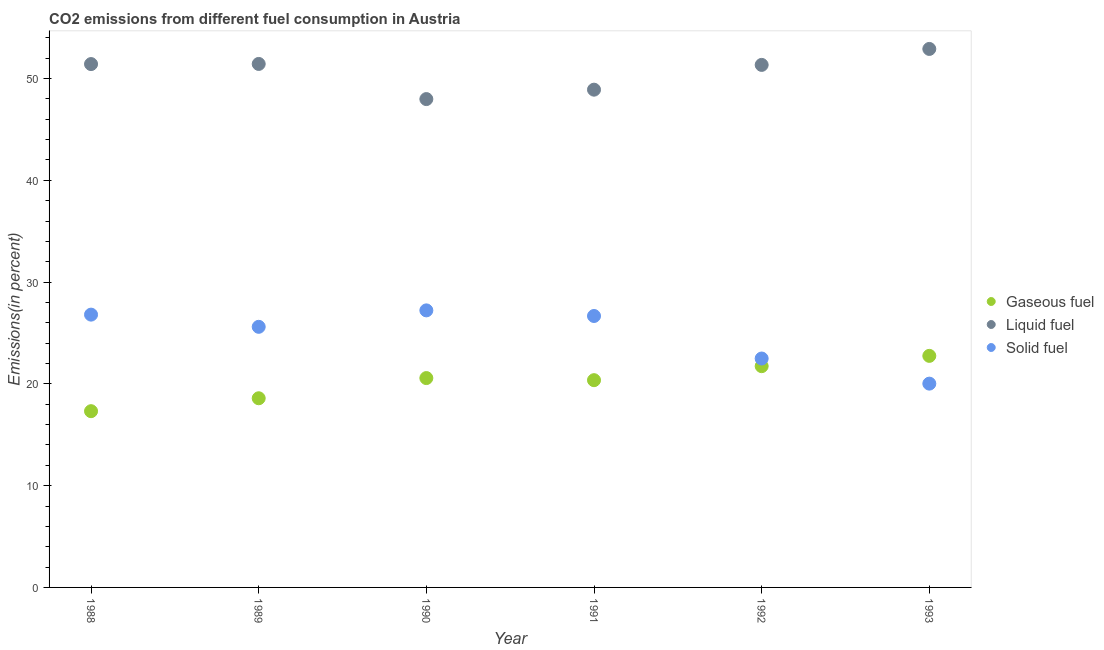How many different coloured dotlines are there?
Give a very brief answer. 3. What is the percentage of gaseous fuel emission in 1991?
Your response must be concise. 20.36. Across all years, what is the maximum percentage of liquid fuel emission?
Provide a succinct answer. 52.91. Across all years, what is the minimum percentage of gaseous fuel emission?
Keep it short and to the point. 17.32. In which year was the percentage of liquid fuel emission maximum?
Your answer should be very brief. 1993. What is the total percentage of liquid fuel emission in the graph?
Your answer should be very brief. 304. What is the difference between the percentage of gaseous fuel emission in 1992 and that in 1993?
Keep it short and to the point. -1.01. What is the difference between the percentage of gaseous fuel emission in 1993 and the percentage of solid fuel emission in 1991?
Your answer should be compact. -3.92. What is the average percentage of gaseous fuel emission per year?
Offer a very short reply. 20.22. In the year 1990, what is the difference between the percentage of liquid fuel emission and percentage of gaseous fuel emission?
Your answer should be compact. 27.41. In how many years, is the percentage of solid fuel emission greater than 20 %?
Your answer should be very brief. 6. What is the ratio of the percentage of liquid fuel emission in 1988 to that in 1993?
Your answer should be very brief. 0.97. Is the percentage of gaseous fuel emission in 1989 less than that in 1992?
Make the answer very short. Yes. What is the difference between the highest and the second highest percentage of solid fuel emission?
Your answer should be very brief. 0.42. What is the difference between the highest and the lowest percentage of solid fuel emission?
Keep it short and to the point. 7.2. In how many years, is the percentage of liquid fuel emission greater than the average percentage of liquid fuel emission taken over all years?
Your answer should be compact. 4. Does the percentage of gaseous fuel emission monotonically increase over the years?
Offer a terse response. No. Is the percentage of liquid fuel emission strictly greater than the percentage of solid fuel emission over the years?
Your answer should be compact. Yes. How many dotlines are there?
Give a very brief answer. 3. How many years are there in the graph?
Give a very brief answer. 6. What is the difference between two consecutive major ticks on the Y-axis?
Make the answer very short. 10. Are the values on the major ticks of Y-axis written in scientific E-notation?
Keep it short and to the point. No. What is the title of the graph?
Your answer should be very brief. CO2 emissions from different fuel consumption in Austria. What is the label or title of the Y-axis?
Give a very brief answer. Emissions(in percent). What is the Emissions(in percent) in Gaseous fuel in 1988?
Make the answer very short. 17.32. What is the Emissions(in percent) in Liquid fuel in 1988?
Your answer should be compact. 51.42. What is the Emissions(in percent) in Solid fuel in 1988?
Provide a short and direct response. 26.8. What is the Emissions(in percent) of Gaseous fuel in 1989?
Provide a short and direct response. 18.59. What is the Emissions(in percent) of Liquid fuel in 1989?
Your answer should be compact. 51.44. What is the Emissions(in percent) in Solid fuel in 1989?
Your answer should be very brief. 25.61. What is the Emissions(in percent) in Gaseous fuel in 1990?
Ensure brevity in your answer.  20.57. What is the Emissions(in percent) in Liquid fuel in 1990?
Offer a terse response. 47.98. What is the Emissions(in percent) in Solid fuel in 1990?
Your answer should be very brief. 27.22. What is the Emissions(in percent) in Gaseous fuel in 1991?
Provide a succinct answer. 20.36. What is the Emissions(in percent) in Liquid fuel in 1991?
Make the answer very short. 48.91. What is the Emissions(in percent) in Solid fuel in 1991?
Give a very brief answer. 26.67. What is the Emissions(in percent) in Gaseous fuel in 1992?
Offer a very short reply. 21.74. What is the Emissions(in percent) of Liquid fuel in 1992?
Provide a succinct answer. 51.34. What is the Emissions(in percent) of Solid fuel in 1992?
Offer a very short reply. 22.49. What is the Emissions(in percent) of Gaseous fuel in 1993?
Your answer should be compact. 22.75. What is the Emissions(in percent) in Liquid fuel in 1993?
Keep it short and to the point. 52.91. What is the Emissions(in percent) in Solid fuel in 1993?
Provide a short and direct response. 20.02. Across all years, what is the maximum Emissions(in percent) in Gaseous fuel?
Your answer should be very brief. 22.75. Across all years, what is the maximum Emissions(in percent) of Liquid fuel?
Ensure brevity in your answer.  52.91. Across all years, what is the maximum Emissions(in percent) of Solid fuel?
Offer a terse response. 27.22. Across all years, what is the minimum Emissions(in percent) of Gaseous fuel?
Ensure brevity in your answer.  17.32. Across all years, what is the minimum Emissions(in percent) of Liquid fuel?
Your response must be concise. 47.98. Across all years, what is the minimum Emissions(in percent) of Solid fuel?
Provide a short and direct response. 20.02. What is the total Emissions(in percent) of Gaseous fuel in the graph?
Offer a very short reply. 121.33. What is the total Emissions(in percent) in Liquid fuel in the graph?
Ensure brevity in your answer.  304. What is the total Emissions(in percent) in Solid fuel in the graph?
Ensure brevity in your answer.  148.82. What is the difference between the Emissions(in percent) of Gaseous fuel in 1988 and that in 1989?
Your response must be concise. -1.27. What is the difference between the Emissions(in percent) of Liquid fuel in 1988 and that in 1989?
Ensure brevity in your answer.  -0.01. What is the difference between the Emissions(in percent) of Solid fuel in 1988 and that in 1989?
Your response must be concise. 1.2. What is the difference between the Emissions(in percent) in Gaseous fuel in 1988 and that in 1990?
Your answer should be compact. -3.25. What is the difference between the Emissions(in percent) in Liquid fuel in 1988 and that in 1990?
Provide a short and direct response. 3.44. What is the difference between the Emissions(in percent) in Solid fuel in 1988 and that in 1990?
Offer a terse response. -0.42. What is the difference between the Emissions(in percent) in Gaseous fuel in 1988 and that in 1991?
Provide a short and direct response. -3.05. What is the difference between the Emissions(in percent) in Liquid fuel in 1988 and that in 1991?
Provide a short and direct response. 2.51. What is the difference between the Emissions(in percent) of Solid fuel in 1988 and that in 1991?
Offer a terse response. 0.13. What is the difference between the Emissions(in percent) in Gaseous fuel in 1988 and that in 1992?
Provide a succinct answer. -4.42. What is the difference between the Emissions(in percent) of Liquid fuel in 1988 and that in 1992?
Ensure brevity in your answer.  0.08. What is the difference between the Emissions(in percent) in Solid fuel in 1988 and that in 1992?
Your response must be concise. 4.31. What is the difference between the Emissions(in percent) in Gaseous fuel in 1988 and that in 1993?
Your answer should be very brief. -5.43. What is the difference between the Emissions(in percent) in Liquid fuel in 1988 and that in 1993?
Make the answer very short. -1.49. What is the difference between the Emissions(in percent) in Solid fuel in 1988 and that in 1993?
Offer a very short reply. 6.78. What is the difference between the Emissions(in percent) of Gaseous fuel in 1989 and that in 1990?
Give a very brief answer. -1.98. What is the difference between the Emissions(in percent) of Liquid fuel in 1989 and that in 1990?
Your response must be concise. 3.45. What is the difference between the Emissions(in percent) of Solid fuel in 1989 and that in 1990?
Your response must be concise. -1.62. What is the difference between the Emissions(in percent) of Gaseous fuel in 1989 and that in 1991?
Ensure brevity in your answer.  -1.78. What is the difference between the Emissions(in percent) in Liquid fuel in 1989 and that in 1991?
Your answer should be compact. 2.53. What is the difference between the Emissions(in percent) of Solid fuel in 1989 and that in 1991?
Ensure brevity in your answer.  -1.06. What is the difference between the Emissions(in percent) in Gaseous fuel in 1989 and that in 1992?
Your answer should be compact. -3.15. What is the difference between the Emissions(in percent) of Liquid fuel in 1989 and that in 1992?
Make the answer very short. 0.09. What is the difference between the Emissions(in percent) of Solid fuel in 1989 and that in 1992?
Your answer should be compact. 3.11. What is the difference between the Emissions(in percent) of Gaseous fuel in 1989 and that in 1993?
Your answer should be compact. -4.17. What is the difference between the Emissions(in percent) in Liquid fuel in 1989 and that in 1993?
Your response must be concise. -1.47. What is the difference between the Emissions(in percent) of Solid fuel in 1989 and that in 1993?
Give a very brief answer. 5.58. What is the difference between the Emissions(in percent) in Gaseous fuel in 1990 and that in 1991?
Provide a short and direct response. 0.21. What is the difference between the Emissions(in percent) of Liquid fuel in 1990 and that in 1991?
Offer a very short reply. -0.93. What is the difference between the Emissions(in percent) of Solid fuel in 1990 and that in 1991?
Give a very brief answer. 0.55. What is the difference between the Emissions(in percent) in Gaseous fuel in 1990 and that in 1992?
Ensure brevity in your answer.  -1.17. What is the difference between the Emissions(in percent) in Liquid fuel in 1990 and that in 1992?
Keep it short and to the point. -3.36. What is the difference between the Emissions(in percent) in Solid fuel in 1990 and that in 1992?
Provide a short and direct response. 4.73. What is the difference between the Emissions(in percent) of Gaseous fuel in 1990 and that in 1993?
Provide a succinct answer. -2.18. What is the difference between the Emissions(in percent) of Liquid fuel in 1990 and that in 1993?
Offer a terse response. -4.93. What is the difference between the Emissions(in percent) of Solid fuel in 1990 and that in 1993?
Offer a terse response. 7.2. What is the difference between the Emissions(in percent) in Gaseous fuel in 1991 and that in 1992?
Keep it short and to the point. -1.38. What is the difference between the Emissions(in percent) of Liquid fuel in 1991 and that in 1992?
Your answer should be compact. -2.43. What is the difference between the Emissions(in percent) of Solid fuel in 1991 and that in 1992?
Offer a terse response. 4.18. What is the difference between the Emissions(in percent) of Gaseous fuel in 1991 and that in 1993?
Provide a short and direct response. -2.39. What is the difference between the Emissions(in percent) in Liquid fuel in 1991 and that in 1993?
Provide a succinct answer. -4. What is the difference between the Emissions(in percent) in Solid fuel in 1991 and that in 1993?
Ensure brevity in your answer.  6.65. What is the difference between the Emissions(in percent) in Gaseous fuel in 1992 and that in 1993?
Ensure brevity in your answer.  -1.01. What is the difference between the Emissions(in percent) in Liquid fuel in 1992 and that in 1993?
Offer a terse response. -1.57. What is the difference between the Emissions(in percent) in Solid fuel in 1992 and that in 1993?
Keep it short and to the point. 2.47. What is the difference between the Emissions(in percent) of Gaseous fuel in 1988 and the Emissions(in percent) of Liquid fuel in 1989?
Your answer should be very brief. -34.12. What is the difference between the Emissions(in percent) in Gaseous fuel in 1988 and the Emissions(in percent) in Solid fuel in 1989?
Offer a very short reply. -8.29. What is the difference between the Emissions(in percent) in Liquid fuel in 1988 and the Emissions(in percent) in Solid fuel in 1989?
Give a very brief answer. 25.82. What is the difference between the Emissions(in percent) of Gaseous fuel in 1988 and the Emissions(in percent) of Liquid fuel in 1990?
Offer a very short reply. -30.67. What is the difference between the Emissions(in percent) in Gaseous fuel in 1988 and the Emissions(in percent) in Solid fuel in 1990?
Give a very brief answer. -9.9. What is the difference between the Emissions(in percent) in Liquid fuel in 1988 and the Emissions(in percent) in Solid fuel in 1990?
Offer a terse response. 24.2. What is the difference between the Emissions(in percent) in Gaseous fuel in 1988 and the Emissions(in percent) in Liquid fuel in 1991?
Offer a very short reply. -31.59. What is the difference between the Emissions(in percent) in Gaseous fuel in 1988 and the Emissions(in percent) in Solid fuel in 1991?
Provide a succinct answer. -9.35. What is the difference between the Emissions(in percent) of Liquid fuel in 1988 and the Emissions(in percent) of Solid fuel in 1991?
Make the answer very short. 24.75. What is the difference between the Emissions(in percent) of Gaseous fuel in 1988 and the Emissions(in percent) of Liquid fuel in 1992?
Your answer should be very brief. -34.02. What is the difference between the Emissions(in percent) of Gaseous fuel in 1988 and the Emissions(in percent) of Solid fuel in 1992?
Your answer should be very brief. -5.17. What is the difference between the Emissions(in percent) of Liquid fuel in 1988 and the Emissions(in percent) of Solid fuel in 1992?
Ensure brevity in your answer.  28.93. What is the difference between the Emissions(in percent) of Gaseous fuel in 1988 and the Emissions(in percent) of Liquid fuel in 1993?
Keep it short and to the point. -35.59. What is the difference between the Emissions(in percent) of Gaseous fuel in 1988 and the Emissions(in percent) of Solid fuel in 1993?
Keep it short and to the point. -2.71. What is the difference between the Emissions(in percent) of Liquid fuel in 1988 and the Emissions(in percent) of Solid fuel in 1993?
Offer a very short reply. 31.4. What is the difference between the Emissions(in percent) in Gaseous fuel in 1989 and the Emissions(in percent) in Liquid fuel in 1990?
Provide a short and direct response. -29.4. What is the difference between the Emissions(in percent) in Gaseous fuel in 1989 and the Emissions(in percent) in Solid fuel in 1990?
Ensure brevity in your answer.  -8.64. What is the difference between the Emissions(in percent) of Liquid fuel in 1989 and the Emissions(in percent) of Solid fuel in 1990?
Keep it short and to the point. 24.21. What is the difference between the Emissions(in percent) in Gaseous fuel in 1989 and the Emissions(in percent) in Liquid fuel in 1991?
Your response must be concise. -30.32. What is the difference between the Emissions(in percent) in Gaseous fuel in 1989 and the Emissions(in percent) in Solid fuel in 1991?
Your response must be concise. -8.08. What is the difference between the Emissions(in percent) in Liquid fuel in 1989 and the Emissions(in percent) in Solid fuel in 1991?
Provide a short and direct response. 24.77. What is the difference between the Emissions(in percent) in Gaseous fuel in 1989 and the Emissions(in percent) in Liquid fuel in 1992?
Offer a very short reply. -32.76. What is the difference between the Emissions(in percent) in Gaseous fuel in 1989 and the Emissions(in percent) in Solid fuel in 1992?
Offer a terse response. -3.91. What is the difference between the Emissions(in percent) in Liquid fuel in 1989 and the Emissions(in percent) in Solid fuel in 1992?
Your answer should be very brief. 28.94. What is the difference between the Emissions(in percent) of Gaseous fuel in 1989 and the Emissions(in percent) of Liquid fuel in 1993?
Your answer should be very brief. -34.32. What is the difference between the Emissions(in percent) in Gaseous fuel in 1989 and the Emissions(in percent) in Solid fuel in 1993?
Your answer should be compact. -1.44. What is the difference between the Emissions(in percent) of Liquid fuel in 1989 and the Emissions(in percent) of Solid fuel in 1993?
Your answer should be compact. 31.41. What is the difference between the Emissions(in percent) in Gaseous fuel in 1990 and the Emissions(in percent) in Liquid fuel in 1991?
Your answer should be compact. -28.34. What is the difference between the Emissions(in percent) in Gaseous fuel in 1990 and the Emissions(in percent) in Solid fuel in 1991?
Offer a terse response. -6.1. What is the difference between the Emissions(in percent) in Liquid fuel in 1990 and the Emissions(in percent) in Solid fuel in 1991?
Provide a short and direct response. 21.31. What is the difference between the Emissions(in percent) of Gaseous fuel in 1990 and the Emissions(in percent) of Liquid fuel in 1992?
Your answer should be compact. -30.77. What is the difference between the Emissions(in percent) in Gaseous fuel in 1990 and the Emissions(in percent) in Solid fuel in 1992?
Your answer should be compact. -1.92. What is the difference between the Emissions(in percent) of Liquid fuel in 1990 and the Emissions(in percent) of Solid fuel in 1992?
Give a very brief answer. 25.49. What is the difference between the Emissions(in percent) in Gaseous fuel in 1990 and the Emissions(in percent) in Liquid fuel in 1993?
Your answer should be compact. -32.34. What is the difference between the Emissions(in percent) in Gaseous fuel in 1990 and the Emissions(in percent) in Solid fuel in 1993?
Your response must be concise. 0.55. What is the difference between the Emissions(in percent) of Liquid fuel in 1990 and the Emissions(in percent) of Solid fuel in 1993?
Your answer should be very brief. 27.96. What is the difference between the Emissions(in percent) of Gaseous fuel in 1991 and the Emissions(in percent) of Liquid fuel in 1992?
Your answer should be compact. -30.98. What is the difference between the Emissions(in percent) of Gaseous fuel in 1991 and the Emissions(in percent) of Solid fuel in 1992?
Offer a terse response. -2.13. What is the difference between the Emissions(in percent) of Liquid fuel in 1991 and the Emissions(in percent) of Solid fuel in 1992?
Provide a succinct answer. 26.42. What is the difference between the Emissions(in percent) of Gaseous fuel in 1991 and the Emissions(in percent) of Liquid fuel in 1993?
Give a very brief answer. -32.55. What is the difference between the Emissions(in percent) of Gaseous fuel in 1991 and the Emissions(in percent) of Solid fuel in 1993?
Your answer should be very brief. 0.34. What is the difference between the Emissions(in percent) in Liquid fuel in 1991 and the Emissions(in percent) in Solid fuel in 1993?
Keep it short and to the point. 28.88. What is the difference between the Emissions(in percent) of Gaseous fuel in 1992 and the Emissions(in percent) of Liquid fuel in 1993?
Offer a terse response. -31.17. What is the difference between the Emissions(in percent) in Gaseous fuel in 1992 and the Emissions(in percent) in Solid fuel in 1993?
Provide a short and direct response. 1.72. What is the difference between the Emissions(in percent) of Liquid fuel in 1992 and the Emissions(in percent) of Solid fuel in 1993?
Offer a very short reply. 31.32. What is the average Emissions(in percent) in Gaseous fuel per year?
Provide a succinct answer. 20.22. What is the average Emissions(in percent) of Liquid fuel per year?
Your answer should be very brief. 50.67. What is the average Emissions(in percent) of Solid fuel per year?
Make the answer very short. 24.8. In the year 1988, what is the difference between the Emissions(in percent) in Gaseous fuel and Emissions(in percent) in Liquid fuel?
Provide a short and direct response. -34.11. In the year 1988, what is the difference between the Emissions(in percent) of Gaseous fuel and Emissions(in percent) of Solid fuel?
Offer a terse response. -9.49. In the year 1988, what is the difference between the Emissions(in percent) in Liquid fuel and Emissions(in percent) in Solid fuel?
Give a very brief answer. 24.62. In the year 1989, what is the difference between the Emissions(in percent) in Gaseous fuel and Emissions(in percent) in Liquid fuel?
Make the answer very short. -32.85. In the year 1989, what is the difference between the Emissions(in percent) in Gaseous fuel and Emissions(in percent) in Solid fuel?
Provide a succinct answer. -7.02. In the year 1989, what is the difference between the Emissions(in percent) of Liquid fuel and Emissions(in percent) of Solid fuel?
Your answer should be very brief. 25.83. In the year 1990, what is the difference between the Emissions(in percent) of Gaseous fuel and Emissions(in percent) of Liquid fuel?
Offer a very short reply. -27.41. In the year 1990, what is the difference between the Emissions(in percent) of Gaseous fuel and Emissions(in percent) of Solid fuel?
Offer a very short reply. -6.65. In the year 1990, what is the difference between the Emissions(in percent) in Liquid fuel and Emissions(in percent) in Solid fuel?
Give a very brief answer. 20.76. In the year 1991, what is the difference between the Emissions(in percent) in Gaseous fuel and Emissions(in percent) in Liquid fuel?
Your answer should be compact. -28.54. In the year 1991, what is the difference between the Emissions(in percent) in Gaseous fuel and Emissions(in percent) in Solid fuel?
Make the answer very short. -6.31. In the year 1991, what is the difference between the Emissions(in percent) in Liquid fuel and Emissions(in percent) in Solid fuel?
Ensure brevity in your answer.  22.24. In the year 1992, what is the difference between the Emissions(in percent) in Gaseous fuel and Emissions(in percent) in Liquid fuel?
Ensure brevity in your answer.  -29.6. In the year 1992, what is the difference between the Emissions(in percent) of Gaseous fuel and Emissions(in percent) of Solid fuel?
Ensure brevity in your answer.  -0.75. In the year 1992, what is the difference between the Emissions(in percent) in Liquid fuel and Emissions(in percent) in Solid fuel?
Your answer should be very brief. 28.85. In the year 1993, what is the difference between the Emissions(in percent) of Gaseous fuel and Emissions(in percent) of Liquid fuel?
Ensure brevity in your answer.  -30.16. In the year 1993, what is the difference between the Emissions(in percent) of Gaseous fuel and Emissions(in percent) of Solid fuel?
Provide a succinct answer. 2.73. In the year 1993, what is the difference between the Emissions(in percent) in Liquid fuel and Emissions(in percent) in Solid fuel?
Offer a very short reply. 32.89. What is the ratio of the Emissions(in percent) in Gaseous fuel in 1988 to that in 1989?
Your answer should be compact. 0.93. What is the ratio of the Emissions(in percent) of Liquid fuel in 1988 to that in 1989?
Make the answer very short. 1. What is the ratio of the Emissions(in percent) of Solid fuel in 1988 to that in 1989?
Your answer should be very brief. 1.05. What is the ratio of the Emissions(in percent) in Gaseous fuel in 1988 to that in 1990?
Provide a short and direct response. 0.84. What is the ratio of the Emissions(in percent) in Liquid fuel in 1988 to that in 1990?
Ensure brevity in your answer.  1.07. What is the ratio of the Emissions(in percent) of Solid fuel in 1988 to that in 1990?
Offer a very short reply. 0.98. What is the ratio of the Emissions(in percent) of Gaseous fuel in 1988 to that in 1991?
Your response must be concise. 0.85. What is the ratio of the Emissions(in percent) in Liquid fuel in 1988 to that in 1991?
Your answer should be very brief. 1.05. What is the ratio of the Emissions(in percent) of Solid fuel in 1988 to that in 1991?
Keep it short and to the point. 1. What is the ratio of the Emissions(in percent) of Gaseous fuel in 1988 to that in 1992?
Provide a short and direct response. 0.8. What is the ratio of the Emissions(in percent) of Solid fuel in 1988 to that in 1992?
Provide a short and direct response. 1.19. What is the ratio of the Emissions(in percent) in Gaseous fuel in 1988 to that in 1993?
Keep it short and to the point. 0.76. What is the ratio of the Emissions(in percent) of Liquid fuel in 1988 to that in 1993?
Keep it short and to the point. 0.97. What is the ratio of the Emissions(in percent) of Solid fuel in 1988 to that in 1993?
Your response must be concise. 1.34. What is the ratio of the Emissions(in percent) of Gaseous fuel in 1989 to that in 1990?
Ensure brevity in your answer.  0.9. What is the ratio of the Emissions(in percent) in Liquid fuel in 1989 to that in 1990?
Ensure brevity in your answer.  1.07. What is the ratio of the Emissions(in percent) in Solid fuel in 1989 to that in 1990?
Make the answer very short. 0.94. What is the ratio of the Emissions(in percent) of Gaseous fuel in 1989 to that in 1991?
Your answer should be compact. 0.91. What is the ratio of the Emissions(in percent) in Liquid fuel in 1989 to that in 1991?
Keep it short and to the point. 1.05. What is the ratio of the Emissions(in percent) in Solid fuel in 1989 to that in 1991?
Give a very brief answer. 0.96. What is the ratio of the Emissions(in percent) in Gaseous fuel in 1989 to that in 1992?
Your answer should be compact. 0.85. What is the ratio of the Emissions(in percent) of Liquid fuel in 1989 to that in 1992?
Make the answer very short. 1. What is the ratio of the Emissions(in percent) in Solid fuel in 1989 to that in 1992?
Provide a succinct answer. 1.14. What is the ratio of the Emissions(in percent) in Gaseous fuel in 1989 to that in 1993?
Ensure brevity in your answer.  0.82. What is the ratio of the Emissions(in percent) of Liquid fuel in 1989 to that in 1993?
Give a very brief answer. 0.97. What is the ratio of the Emissions(in percent) of Solid fuel in 1989 to that in 1993?
Your answer should be compact. 1.28. What is the ratio of the Emissions(in percent) of Liquid fuel in 1990 to that in 1991?
Keep it short and to the point. 0.98. What is the ratio of the Emissions(in percent) in Solid fuel in 1990 to that in 1991?
Make the answer very short. 1.02. What is the ratio of the Emissions(in percent) in Gaseous fuel in 1990 to that in 1992?
Provide a succinct answer. 0.95. What is the ratio of the Emissions(in percent) of Liquid fuel in 1990 to that in 1992?
Your answer should be very brief. 0.93. What is the ratio of the Emissions(in percent) of Solid fuel in 1990 to that in 1992?
Ensure brevity in your answer.  1.21. What is the ratio of the Emissions(in percent) of Gaseous fuel in 1990 to that in 1993?
Make the answer very short. 0.9. What is the ratio of the Emissions(in percent) of Liquid fuel in 1990 to that in 1993?
Make the answer very short. 0.91. What is the ratio of the Emissions(in percent) in Solid fuel in 1990 to that in 1993?
Offer a very short reply. 1.36. What is the ratio of the Emissions(in percent) in Gaseous fuel in 1991 to that in 1992?
Make the answer very short. 0.94. What is the ratio of the Emissions(in percent) of Liquid fuel in 1991 to that in 1992?
Your answer should be very brief. 0.95. What is the ratio of the Emissions(in percent) of Solid fuel in 1991 to that in 1992?
Make the answer very short. 1.19. What is the ratio of the Emissions(in percent) in Gaseous fuel in 1991 to that in 1993?
Keep it short and to the point. 0.9. What is the ratio of the Emissions(in percent) of Liquid fuel in 1991 to that in 1993?
Make the answer very short. 0.92. What is the ratio of the Emissions(in percent) in Solid fuel in 1991 to that in 1993?
Your response must be concise. 1.33. What is the ratio of the Emissions(in percent) of Gaseous fuel in 1992 to that in 1993?
Your response must be concise. 0.96. What is the ratio of the Emissions(in percent) in Liquid fuel in 1992 to that in 1993?
Your answer should be compact. 0.97. What is the ratio of the Emissions(in percent) in Solid fuel in 1992 to that in 1993?
Give a very brief answer. 1.12. What is the difference between the highest and the second highest Emissions(in percent) of Gaseous fuel?
Offer a very short reply. 1.01. What is the difference between the highest and the second highest Emissions(in percent) in Liquid fuel?
Provide a succinct answer. 1.47. What is the difference between the highest and the second highest Emissions(in percent) in Solid fuel?
Your answer should be compact. 0.42. What is the difference between the highest and the lowest Emissions(in percent) in Gaseous fuel?
Offer a terse response. 5.43. What is the difference between the highest and the lowest Emissions(in percent) in Liquid fuel?
Offer a very short reply. 4.93. What is the difference between the highest and the lowest Emissions(in percent) in Solid fuel?
Give a very brief answer. 7.2. 